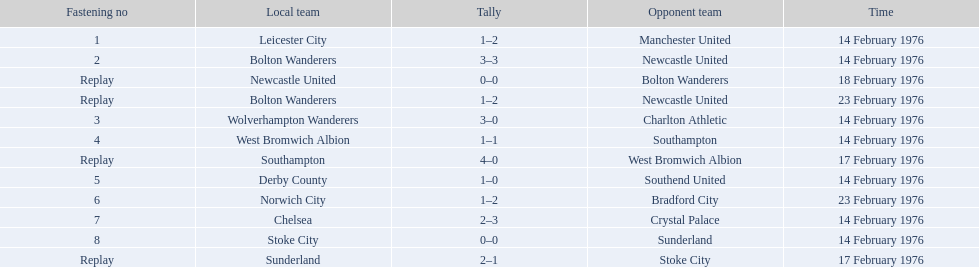Who were all the teams that played? Leicester City, Manchester United, Bolton Wanderers, Newcastle United, Newcastle United, Bolton Wanderers, Bolton Wanderers, Newcastle United, Wolverhampton Wanderers, Charlton Athletic, West Bromwich Albion, Southampton, Southampton, West Bromwich Albion, Derby County, Southend United, Norwich City, Bradford City, Chelsea, Crystal Palace, Stoke City, Sunderland, Sunderland, Stoke City. Which of these teams won? Manchester United, Newcastle United, Wolverhampton Wanderers, Southampton, Derby County, Bradford City, Crystal Palace, Sunderland. What was manchester united's winning score? 1–2. What was the wolverhampton wonders winning score? 3–0. Which of these two teams had the better winning score? Wolverhampton Wanderers. 